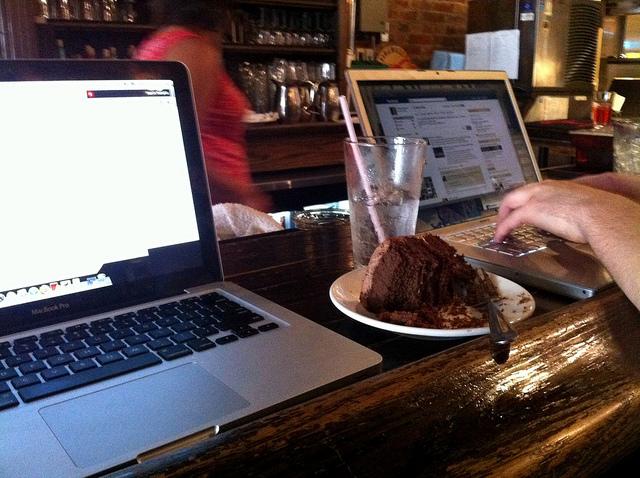Are these laptops for sale?
Write a very short answer. No. What are the laptops?
Concise answer only. Computers. What are they drinking?
Be succinct. Water. Where are these laptops?
Keep it brief. Bar. 